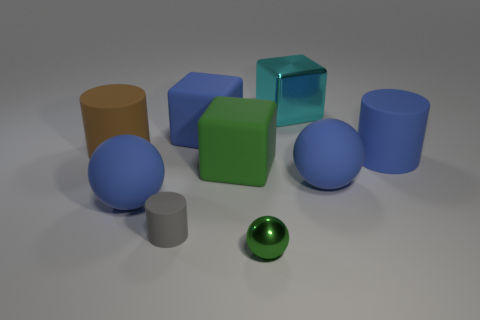Subtract all green rubber cubes. How many cubes are left? 2 Subtract all green cubes. How many cubes are left? 2 Add 1 rubber cylinders. How many objects exist? 10 Add 7 brown things. How many brown things exist? 8 Subtract 0 cyan spheres. How many objects are left? 9 Subtract all balls. How many objects are left? 6 Subtract 1 cylinders. How many cylinders are left? 2 Subtract all yellow cubes. Subtract all cyan cylinders. How many cubes are left? 3 Subtract all purple spheres. How many gray cylinders are left? 1 Subtract all large purple rubber things. Subtract all large blue matte things. How many objects are left? 5 